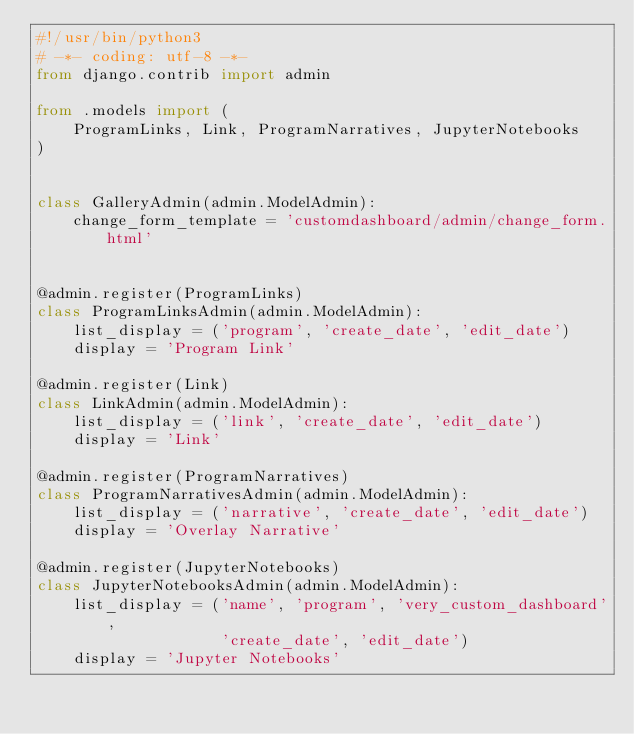Convert code to text. <code><loc_0><loc_0><loc_500><loc_500><_Python_>#!/usr/bin/python3
# -*- coding: utf-8 -*-
from django.contrib import admin

from .models import (
    ProgramLinks, Link, ProgramNarratives, JupyterNotebooks
)


class GalleryAdmin(admin.ModelAdmin):
    change_form_template = 'customdashboard/admin/change_form.html'


@admin.register(ProgramLinks)
class ProgramLinksAdmin(admin.ModelAdmin):
    list_display = ('program', 'create_date', 'edit_date')
    display = 'Program Link'

@admin.register(Link)
class LinkAdmin(admin.ModelAdmin):
    list_display = ('link', 'create_date', 'edit_date')
    display = 'Link'

@admin.register(ProgramNarratives)
class ProgramNarrativesAdmin(admin.ModelAdmin):
    list_display = ('narrative', 'create_date', 'edit_date')
    display = 'Overlay Narrative'

@admin.register(JupyterNotebooks)
class JupyterNotebooksAdmin(admin.ModelAdmin):
    list_display = ('name', 'program', 'very_custom_dashboard',
                    'create_date', 'edit_date')
    display = 'Jupyter Notebooks'
</code> 